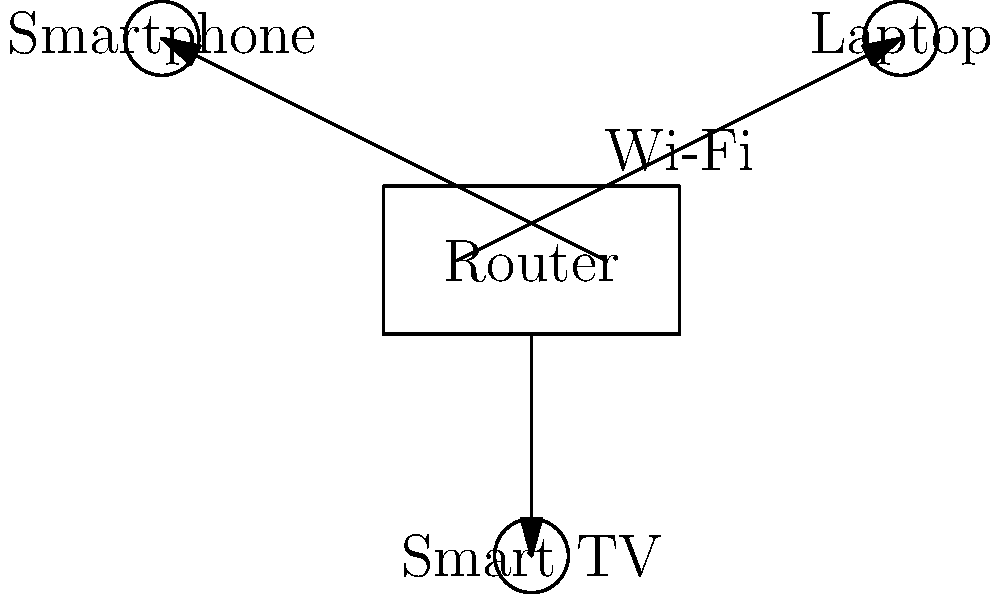In the diagram above, which component is responsible for broadcasting the Wi-Fi signal to connect the devices in a home network? To answer this question, let's break down the components of a typical home Wi-Fi network:

1. Router: This is the central device in the network, represented by the rectangle in the middle of the diagram.
2. Connected devices: These are shown as circles in the diagram, labeled as Laptop, Smartphone, and Smart TV.
3. Wi-Fi signals: These are represented by the arrows connecting the router to the devices.

The key points to consider are:

1. The router is the only device in the diagram that has multiple arrows pointing outward to other devices.
2. The label "Wi-Fi" is placed near the router, indicating that it's the source of the Wi-Fi signal.
3. In a typical home network setup, the router is responsible for creating and broadcasting the Wi-Fi network that other devices connect to.

Therefore, based on the diagram and our understanding of home networks, the router is the component responsible for broadcasting the Wi-Fi signal to connect the devices in a home network.
Answer: Router 